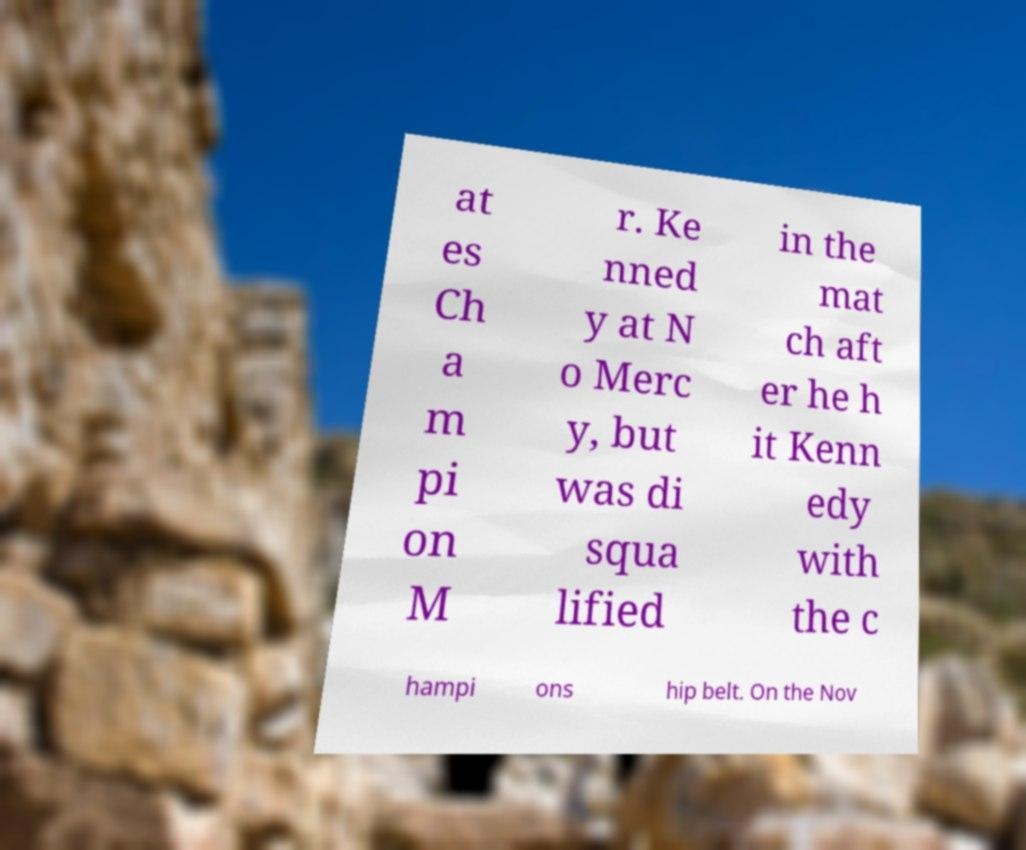Could you assist in decoding the text presented in this image and type it out clearly? at es Ch a m pi on M r. Ke nned y at N o Merc y, but was di squa lified in the mat ch aft er he h it Kenn edy with the c hampi ons hip belt. On the Nov 